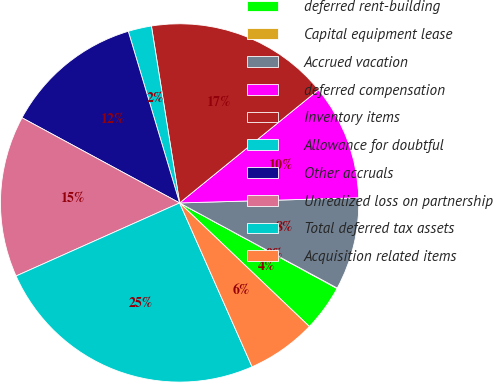<chart> <loc_0><loc_0><loc_500><loc_500><pie_chart><fcel>deferred rent-building<fcel>Capital equipment lease<fcel>Accrued vacation<fcel>deferred compensation<fcel>Inventory items<fcel>Allowance for doubtful<fcel>Other accruals<fcel>Unrealized loss on partnership<fcel>Total deferred tax assets<fcel>Acquisition related items<nl><fcel>4.19%<fcel>0.04%<fcel>8.34%<fcel>10.42%<fcel>16.64%<fcel>2.11%<fcel>12.49%<fcel>14.57%<fcel>24.94%<fcel>6.26%<nl></chart> 